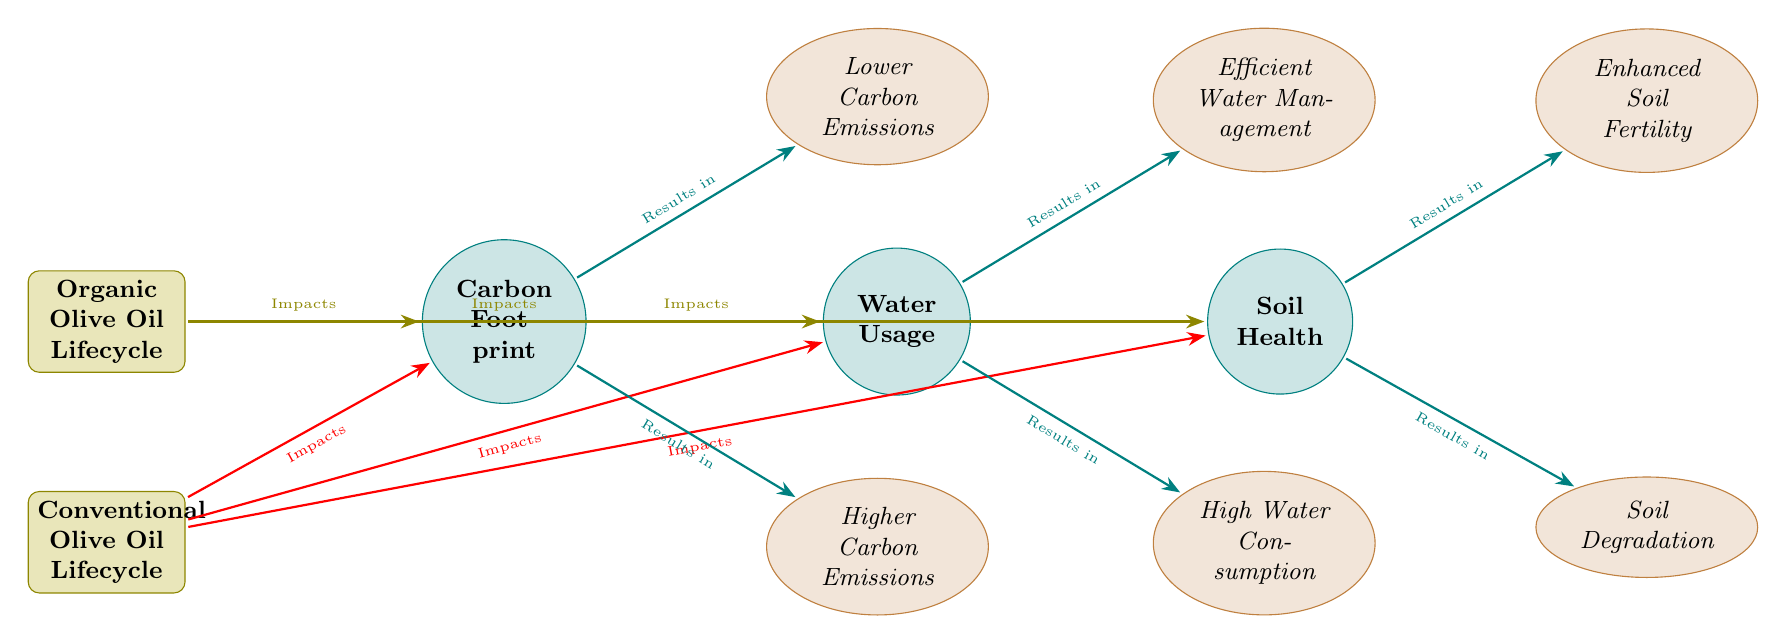What are the two types of olive oil lifecycles compared in the diagram? The two types of olive oil lifecycles compared in the diagram are the Organic Olive Oil Lifecycle and the Conventional Olive Oil Lifecycle.
Answer: Organic and Conventional What impact does organic olive oil production have on carbon emissions? The impact of organic olive oil production on carbon emissions results in Lower Carbon Emissions according to the diagram.
Answer: Lower Carbon Emissions How many factors are analyzed in the diagram related to olive oil production? The diagram analyzes three factors related to olive oil production: Carbon Footprint, Water Usage, and Soil Health.
Answer: Three Which type of olive oil production is associated with high water consumption? Conventional olive oil production is associated with High Water Consumption as depicted in the diagram.
Answer: Conventional What is the relationship between soil health and organic olive oil production? The relationship shows that organic olive oil production results in Enhanced Soil Fertility.
Answer: Enhanced Soil Fertility What overall impact do conventional practices have on soil health? Conventional practices result in Soil Degradation according to the results presented in the diagram.
Answer: Soil Degradation How does the diagram visually distinguish between organic and conventional olive oil impacts? The diagram visually distinguishes the two by using different colors for arrows: olive for organic, red for conventional, indicating positive and negative impacts, respectively.
Answer: Different colors for arrows Which factor leads to efficient water management? The factor that leads to efficient water management is Water Usage associated with Organic Olive Oil Lifecycle.
Answer: Water Usage 